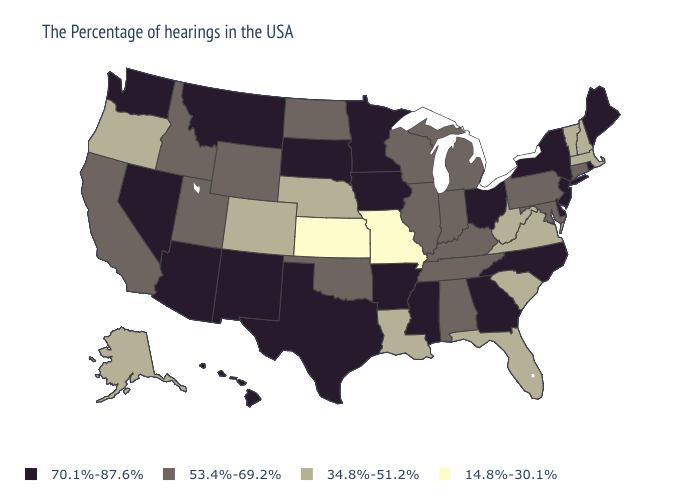Does Oklahoma have the lowest value in the South?
Answer briefly. No. What is the lowest value in states that border Louisiana?
Keep it brief. 70.1%-87.6%. What is the highest value in states that border Washington?
Short answer required. 53.4%-69.2%. What is the value of Virginia?
Keep it brief. 34.8%-51.2%. Does Wyoming have a higher value than Florida?
Concise answer only. Yes. Name the states that have a value in the range 70.1%-87.6%?
Short answer required. Maine, Rhode Island, New York, New Jersey, Delaware, North Carolina, Ohio, Georgia, Mississippi, Arkansas, Minnesota, Iowa, Texas, South Dakota, New Mexico, Montana, Arizona, Nevada, Washington, Hawaii. Name the states that have a value in the range 70.1%-87.6%?
Keep it brief. Maine, Rhode Island, New York, New Jersey, Delaware, North Carolina, Ohio, Georgia, Mississippi, Arkansas, Minnesota, Iowa, Texas, South Dakota, New Mexico, Montana, Arizona, Nevada, Washington, Hawaii. What is the value of Wisconsin?
Write a very short answer. 53.4%-69.2%. Name the states that have a value in the range 53.4%-69.2%?
Concise answer only. Connecticut, Maryland, Pennsylvania, Michigan, Kentucky, Indiana, Alabama, Tennessee, Wisconsin, Illinois, Oklahoma, North Dakota, Wyoming, Utah, Idaho, California. What is the value of California?
Keep it brief. 53.4%-69.2%. What is the value of Indiana?
Concise answer only. 53.4%-69.2%. Does Nevada have the lowest value in the West?
Write a very short answer. No. Which states have the lowest value in the West?
Give a very brief answer. Colorado, Oregon, Alaska. Name the states that have a value in the range 14.8%-30.1%?
Keep it brief. Missouri, Kansas. Among the states that border Massachusetts , which have the highest value?
Keep it brief. Rhode Island, New York. 